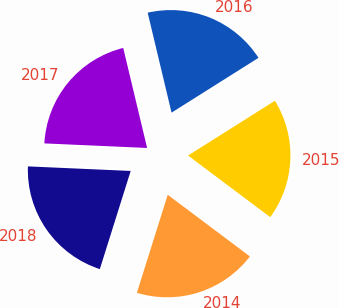Convert chart to OTSL. <chart><loc_0><loc_0><loc_500><loc_500><pie_chart><fcel>2014<fcel>2015<fcel>2016<fcel>2017<fcel>2018<nl><fcel>19.61%<fcel>19.19%<fcel>19.78%<fcel>20.56%<fcel>20.86%<nl></chart> 